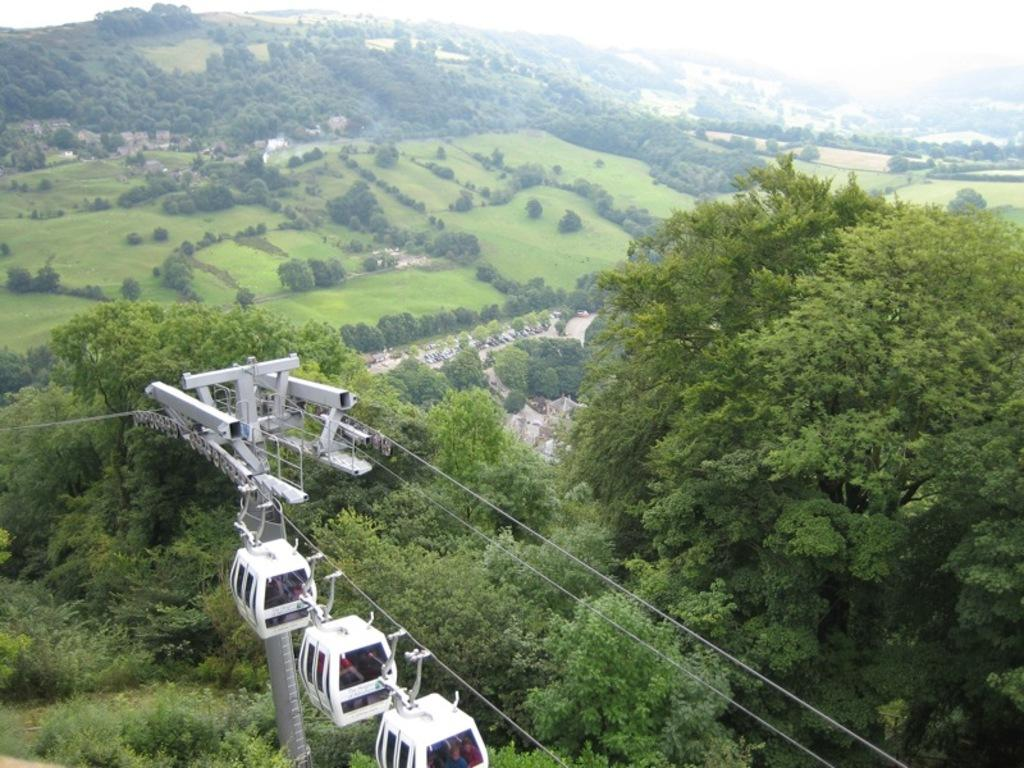What type of transportation is shown in the image? There is a ropeway in the image. What structure can be seen supporting the ropeway? There is a pole in the image. What type of natural environment is visible in the image? There are trees and a hill in the image. What is visible in the background of the image? The sky is visible in the image. What color is the ink on the tooth in the image? There is no ink or tooth present in the image. 